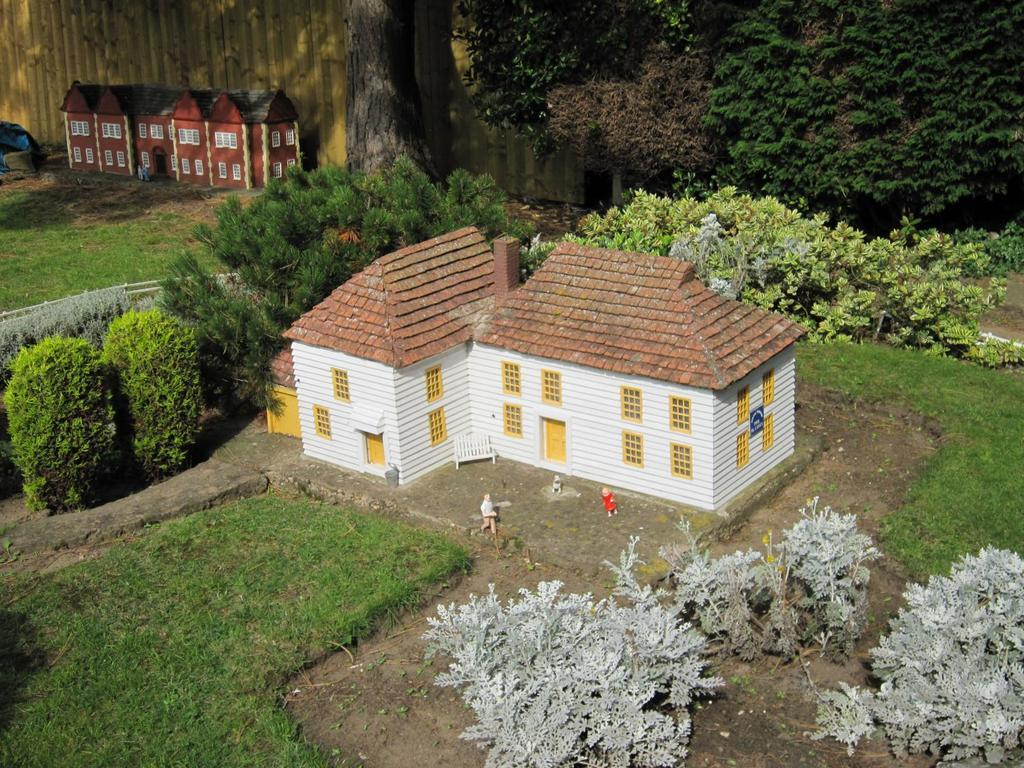What type of objects are featured in the image? There are miniatures in the image. What structure can be seen in the image? There is a building in the image. Who or what else is present in the image? There are people in the image. What type of natural elements are visible in the image? There are plants and trees in the image. What type of seating is available in the backdrop of the image? There are benches in the backdrop of the image. Which leg of the person in the image is longer? There is no person in the image with legs, as it features miniatures. What type of plants are growing on the side of the building in the image? There are no plants growing on the side of the building in the image; only plants and trees are mentioned in the backdrop. 